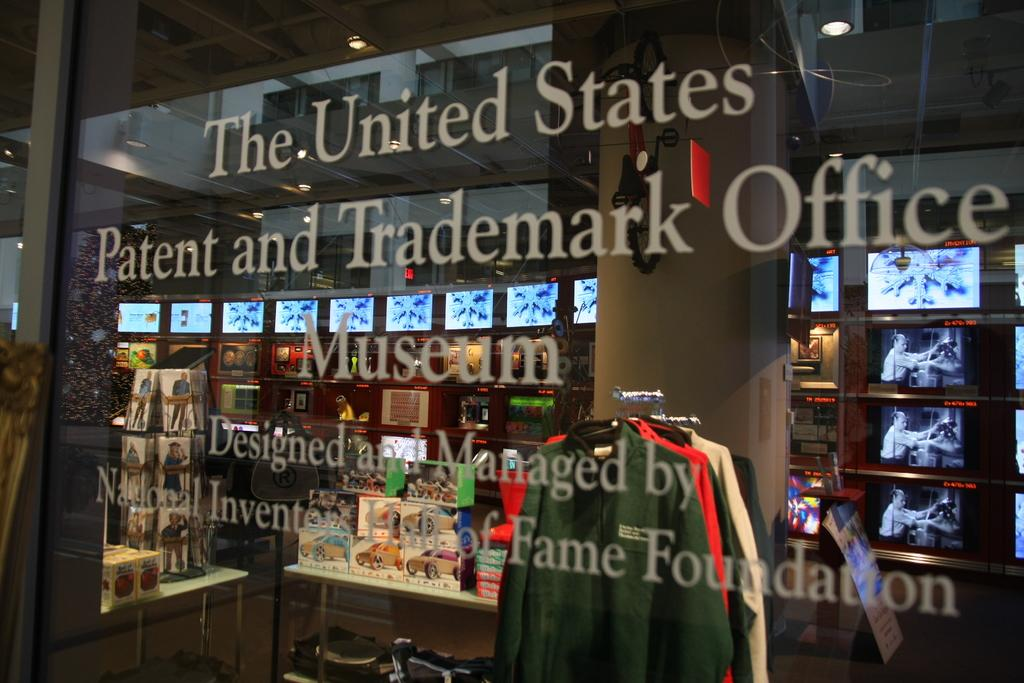<image>
Give a short and clear explanation of the subsequent image. A window of The United States Patent and Trademark Office Museum. 